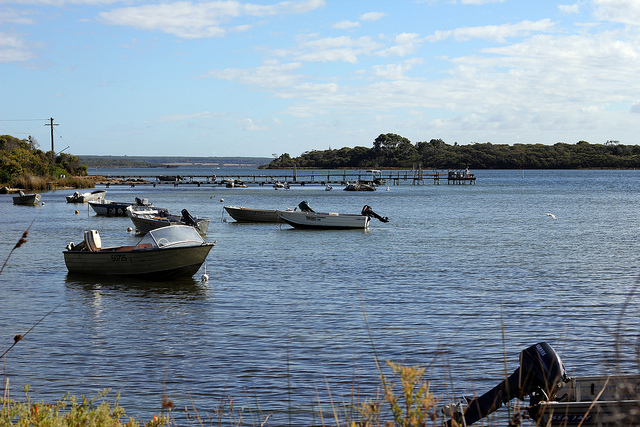Describe the activity on the water. On the peaceful expanse of the lake, a few boats are leisurely floating, many seemingly moored and swaying gently with the subtle movements of the water. The stillness suggests that it's a quiet time, possibly an early morning or late afternoon, with little visible human activity. A bird flies serenely across the scene, adding a gentle touch of wildlife to the tranquil setting. 